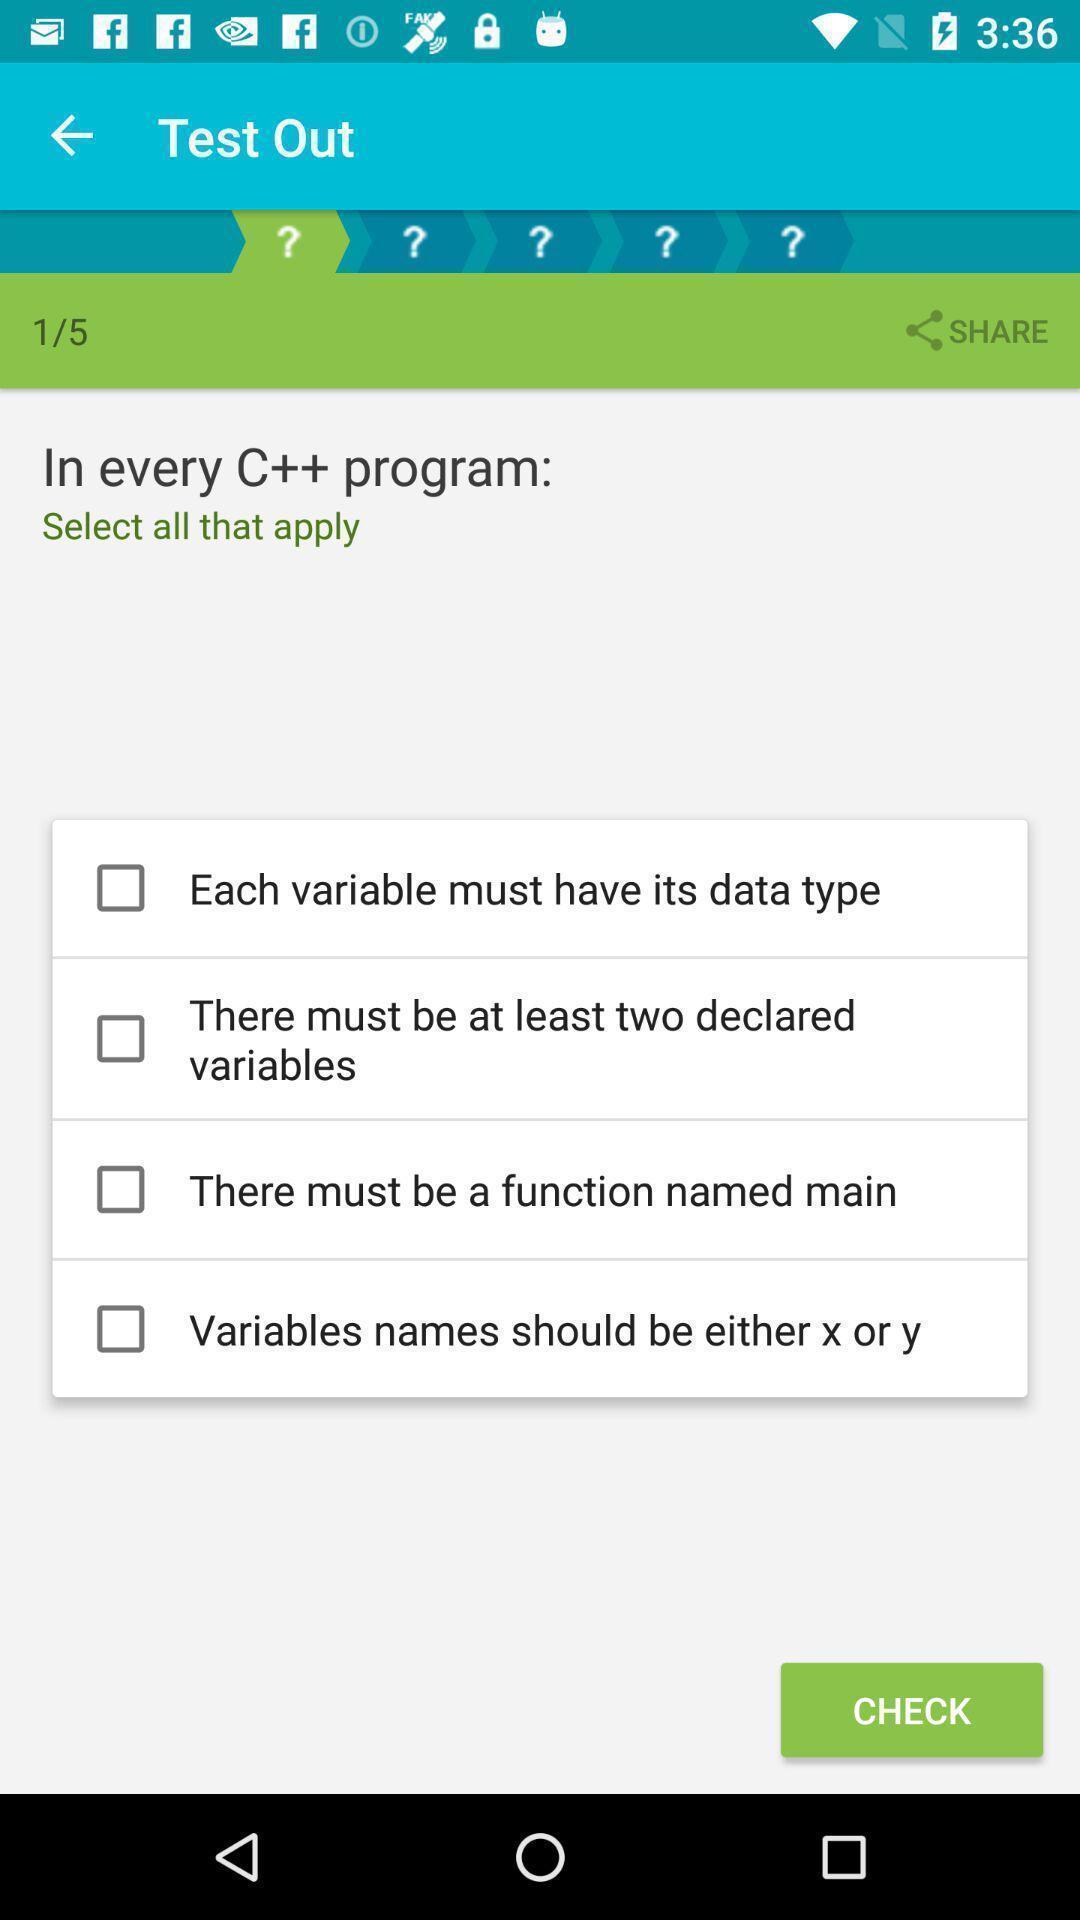Tell me what you see in this picture. Screen page of a learning application. 